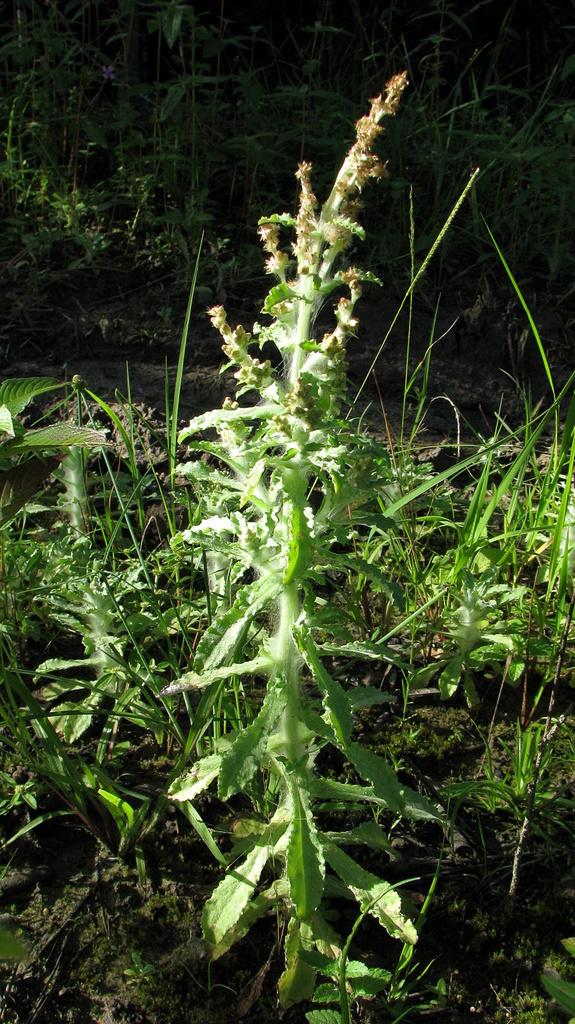What is located in the center of the image? There are plants and grass in the center of the image. Are there any other plants visible in the image? Yes, there are plants in the background of the image. What type of surface can be seen in the background of the image? There is ground visible in the background of the image. What type of spoon can be seen in the image? There is no spoon present in the image. Are the brothers playing in the image? There is no mention of brothers or any play activity in the image. 